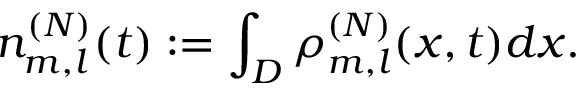Convert formula to latex. <formula><loc_0><loc_0><loc_500><loc_500>n _ { m , l } ^ { ( N ) } ( t ) \colon = \int _ { D } \rho _ { m , l } ^ { ( N ) } ( x , t ) d x .</formula> 